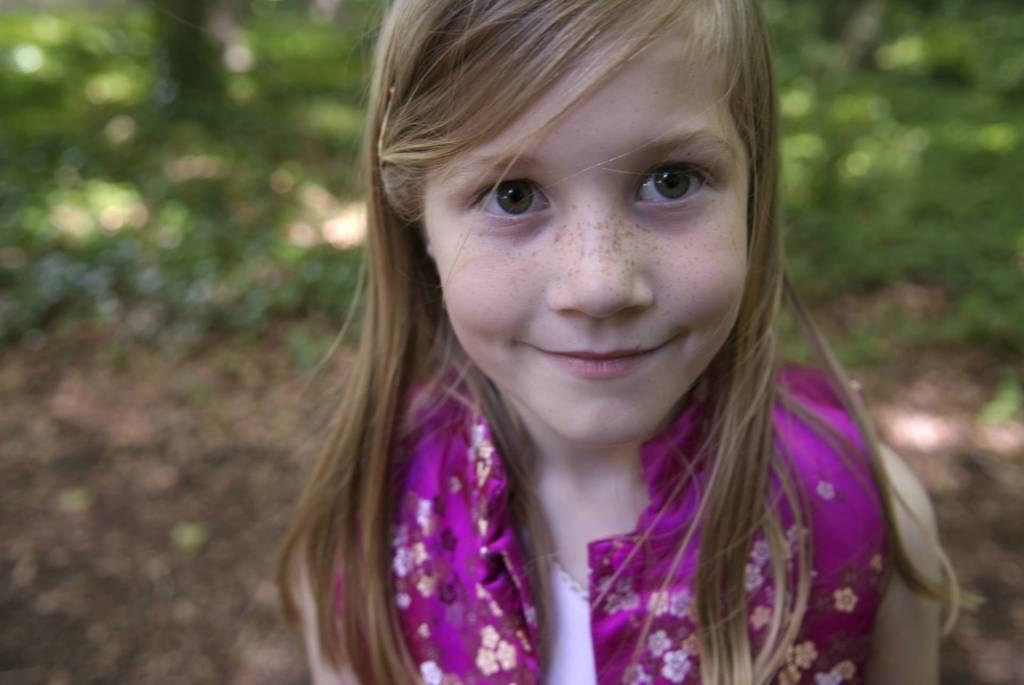Who is the main subject in the image? There is a girl in the image. What else can be seen in the image besides the girl? Plants are visible in the image. What type of noise is the girl making in the image? There is no information about any noise in the image, as it only mentions the presence of a girl and plants. 